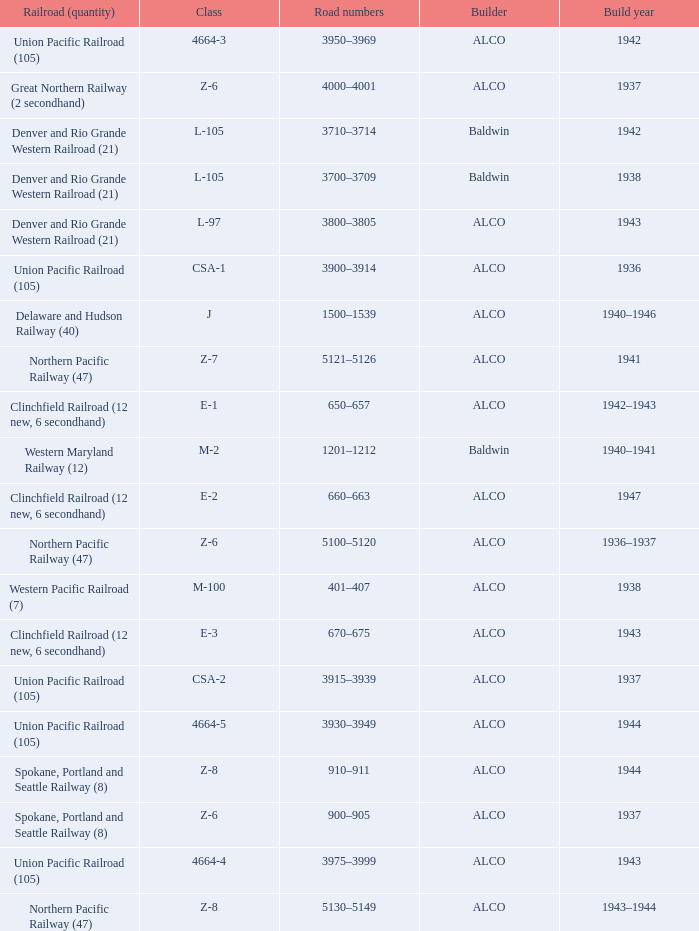Could you parse the entire table as a dict? {'header': ['Railroad (quantity)', 'Class', 'Road numbers', 'Builder', 'Build year'], 'rows': [['Union Pacific Railroad (105)', '4664-3', '3950–3969', 'ALCO', '1942'], ['Great Northern Railway (2 secondhand)', 'Z-6', '4000–4001', 'ALCO', '1937'], ['Denver and Rio Grande Western Railroad (21)', 'L-105', '3710–3714', 'Baldwin', '1942'], ['Denver and Rio Grande Western Railroad (21)', 'L-105', '3700–3709', 'Baldwin', '1938'], ['Denver and Rio Grande Western Railroad (21)', 'L-97', '3800–3805', 'ALCO', '1943'], ['Union Pacific Railroad (105)', 'CSA-1', '3900–3914', 'ALCO', '1936'], ['Delaware and Hudson Railway (40)', 'J', '1500–1539', 'ALCO', '1940–1946'], ['Northern Pacific Railway (47)', 'Z-7', '5121–5126', 'ALCO', '1941'], ['Clinchfield Railroad (12 new, 6 secondhand)', 'E-1', '650–657', 'ALCO', '1942–1943'], ['Western Maryland Railway (12)', 'M-2', '1201–1212', 'Baldwin', '1940–1941'], ['Clinchfield Railroad (12 new, 6 secondhand)', 'E-2', '660–663', 'ALCO', '1947'], ['Northern Pacific Railway (47)', 'Z-6', '5100–5120', 'ALCO', '1936–1937'], ['Western Pacific Railroad (7)', 'M-100', '401–407', 'ALCO', '1938'], ['Clinchfield Railroad (12 new, 6 secondhand)', 'E-3', '670–675', 'ALCO', '1943'], ['Union Pacific Railroad (105)', 'CSA-2', '3915–3939', 'ALCO', '1937'], ['Union Pacific Railroad (105)', '4664-5', '3930–3949', 'ALCO', '1944'], ['Spokane, Portland and Seattle Railway (8)', 'Z-8', '910–911', 'ALCO', '1944'], ['Spokane, Portland and Seattle Railway (8)', 'Z-6', '900–905', 'ALCO', '1937'], ['Union Pacific Railroad (105)', '4664-4', '3975–3999', 'ALCO', '1943'], ['Northern Pacific Railway (47)', 'Z-8', '5130–5149', 'ALCO', '1943–1944']]} What is the road numbers when the builder is alco, the railroad (quantity) is union pacific railroad (105) and the class is csa-2? 3915–3939. 